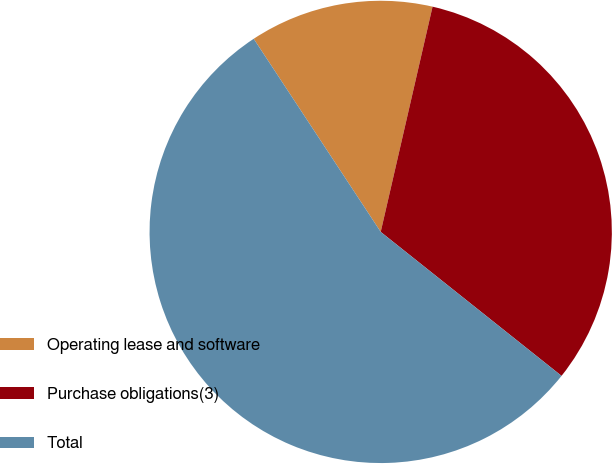<chart> <loc_0><loc_0><loc_500><loc_500><pie_chart><fcel>Operating lease and software<fcel>Purchase obligations(3)<fcel>Total<nl><fcel>12.86%<fcel>32.1%<fcel>55.04%<nl></chart> 